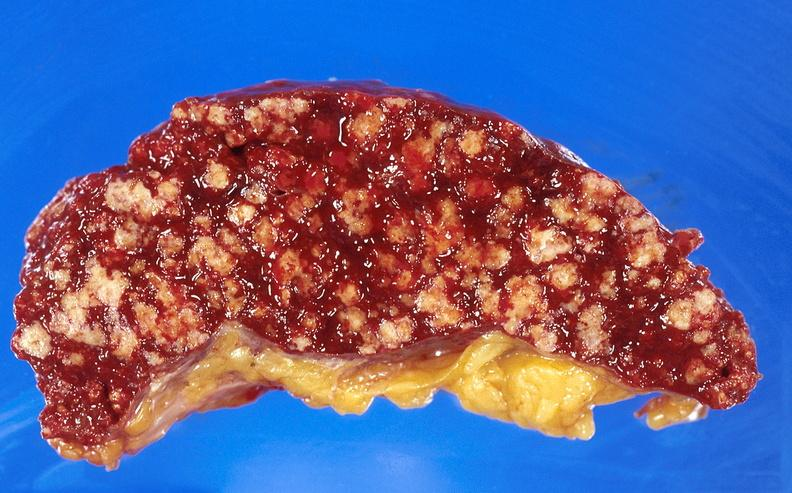s hematologic present?
Answer the question using a single word or phrase. Yes 